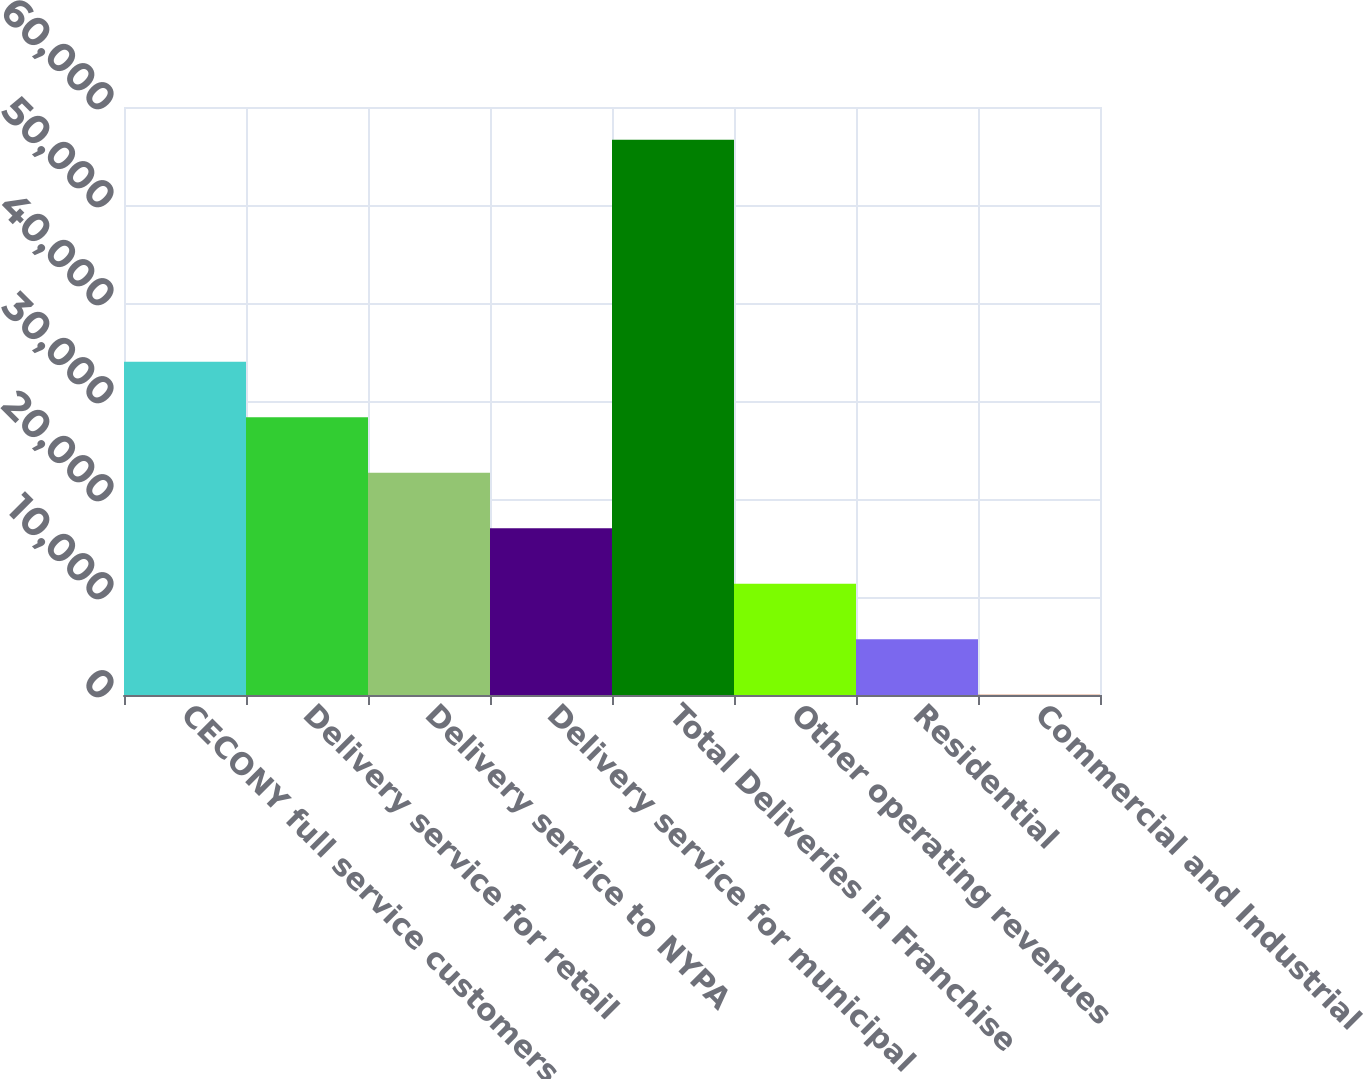Convert chart to OTSL. <chart><loc_0><loc_0><loc_500><loc_500><bar_chart><fcel>CECONY full service customers<fcel>Delivery service for retail<fcel>Delivery service to NYPA<fcel>Delivery service for municipal<fcel>Total Deliveries in Franchise<fcel>Other operating revenues<fcel>Residential<fcel>Commercial and Industrial<nl><fcel>34008<fcel>28343.3<fcel>22678.6<fcel>17013.8<fcel>56667<fcel>11349.1<fcel>5684.34<fcel>19.6<nl></chart> 